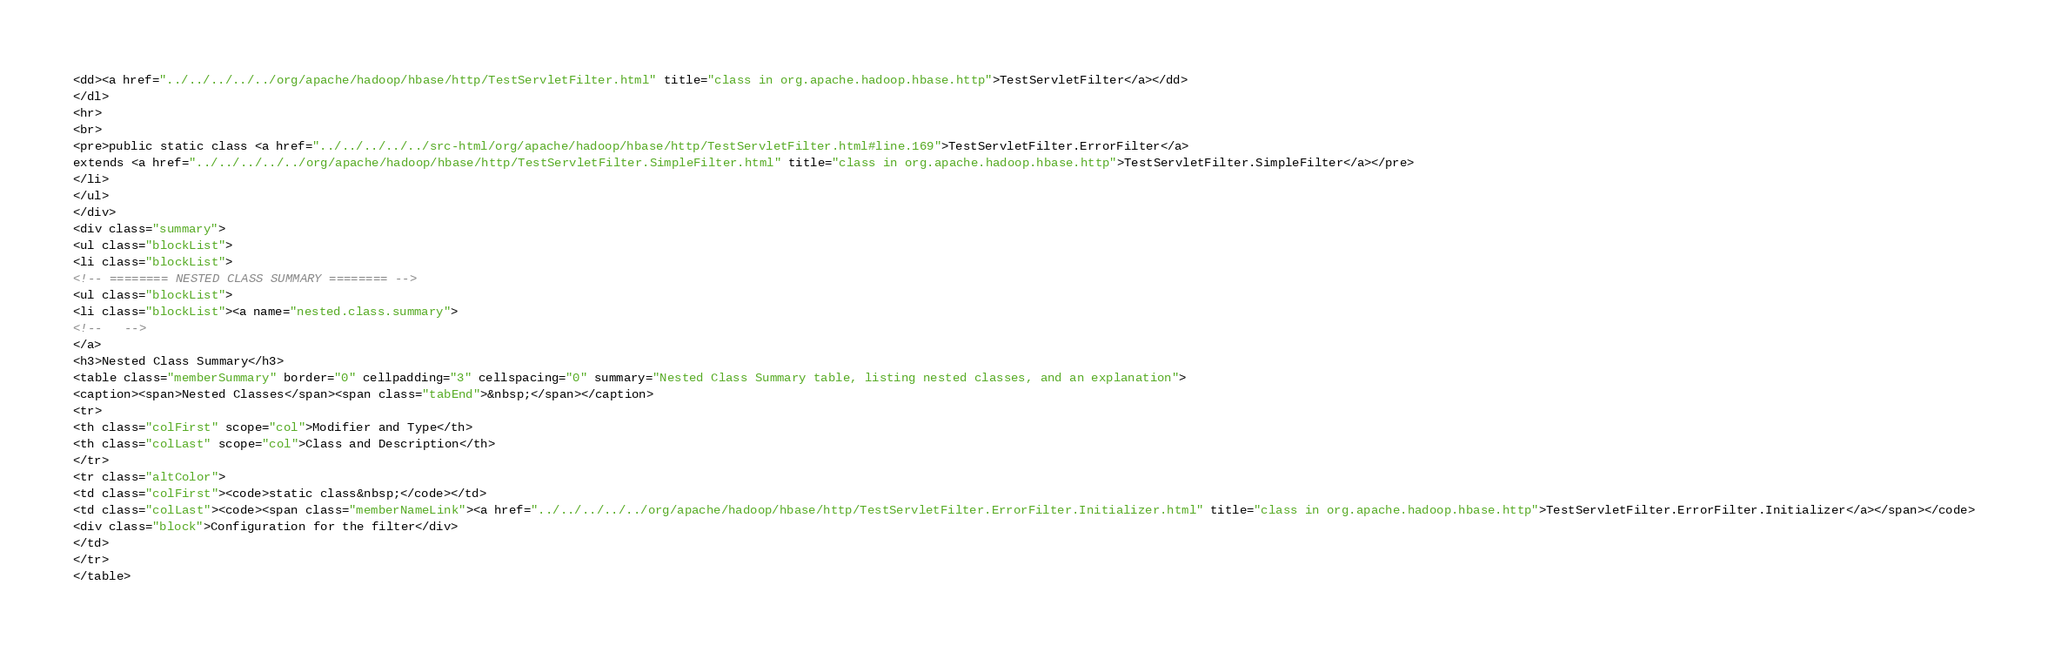Convert code to text. <code><loc_0><loc_0><loc_500><loc_500><_HTML_><dd><a href="../../../../../org/apache/hadoop/hbase/http/TestServletFilter.html" title="class in org.apache.hadoop.hbase.http">TestServletFilter</a></dd>
</dl>
<hr>
<br>
<pre>public static class <a href="../../../../../src-html/org/apache/hadoop/hbase/http/TestServletFilter.html#line.169">TestServletFilter.ErrorFilter</a>
extends <a href="../../../../../org/apache/hadoop/hbase/http/TestServletFilter.SimpleFilter.html" title="class in org.apache.hadoop.hbase.http">TestServletFilter.SimpleFilter</a></pre>
</li>
</ul>
</div>
<div class="summary">
<ul class="blockList">
<li class="blockList">
<!-- ======== NESTED CLASS SUMMARY ======== -->
<ul class="blockList">
<li class="blockList"><a name="nested.class.summary">
<!--   -->
</a>
<h3>Nested Class Summary</h3>
<table class="memberSummary" border="0" cellpadding="3" cellspacing="0" summary="Nested Class Summary table, listing nested classes, and an explanation">
<caption><span>Nested Classes</span><span class="tabEnd">&nbsp;</span></caption>
<tr>
<th class="colFirst" scope="col">Modifier and Type</th>
<th class="colLast" scope="col">Class and Description</th>
</tr>
<tr class="altColor">
<td class="colFirst"><code>static class&nbsp;</code></td>
<td class="colLast"><code><span class="memberNameLink"><a href="../../../../../org/apache/hadoop/hbase/http/TestServletFilter.ErrorFilter.Initializer.html" title="class in org.apache.hadoop.hbase.http">TestServletFilter.ErrorFilter.Initializer</a></span></code>
<div class="block">Configuration for the filter</div>
</td>
</tr>
</table></code> 